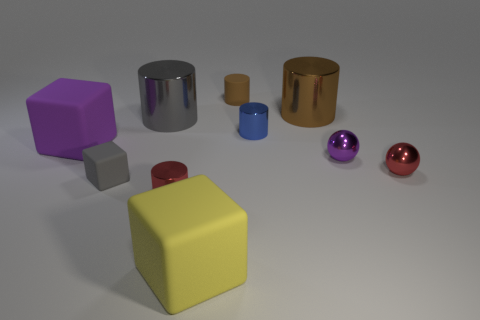How many other big objects are the same shape as the gray rubber thing?
Provide a succinct answer. 2. How big is the brown rubber object behind the big object that is to the left of the large metallic thing to the left of the blue thing?
Your answer should be very brief. Small. Do the gray thing behind the small gray matte cube and the big yellow block have the same material?
Offer a terse response. No. Are there an equal number of tiny blue metallic cylinders left of the tiny gray rubber cube and matte things that are on the right side of the large yellow matte object?
Provide a succinct answer. No. Is there anything else that is the same size as the yellow rubber block?
Provide a short and direct response. Yes. There is another large thing that is the same shape as the big purple matte object; what is it made of?
Offer a terse response. Rubber. Is there a large thing that is behind the big block that is behind the big rubber object that is in front of the purple ball?
Your response must be concise. Yes. Is the shape of the purple object on the left side of the tiny gray object the same as the big shiny thing to the right of the big gray cylinder?
Keep it short and to the point. No. Are there more red objects that are to the left of the large yellow matte cube than yellow cubes?
Provide a short and direct response. No. How many things are either small blue cylinders or big things?
Keep it short and to the point. 5. 